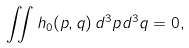<formula> <loc_0><loc_0><loc_500><loc_500>\iint h _ { 0 } ( p , q ) \, d ^ { 3 } p d ^ { 3 } q = 0 ,</formula> 